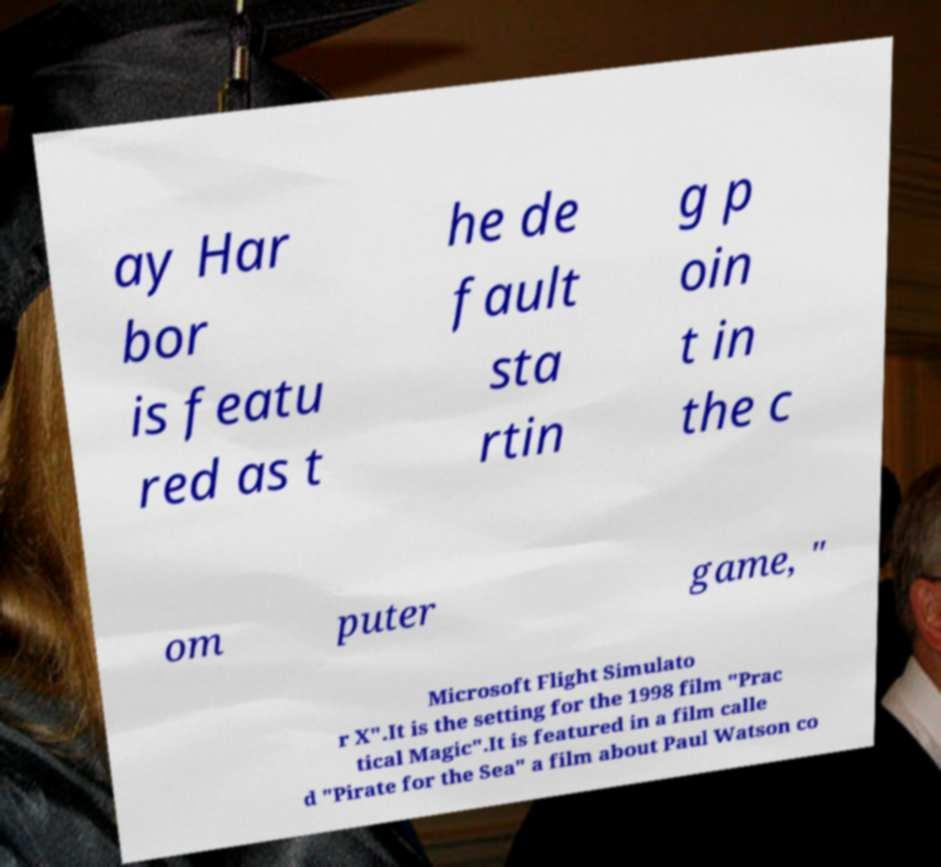There's text embedded in this image that I need extracted. Can you transcribe it verbatim? ay Har bor is featu red as t he de fault sta rtin g p oin t in the c om puter game, " Microsoft Flight Simulato r X".It is the setting for the 1998 film "Prac tical Magic".It is featured in a film calle d "Pirate for the Sea" a film about Paul Watson co 